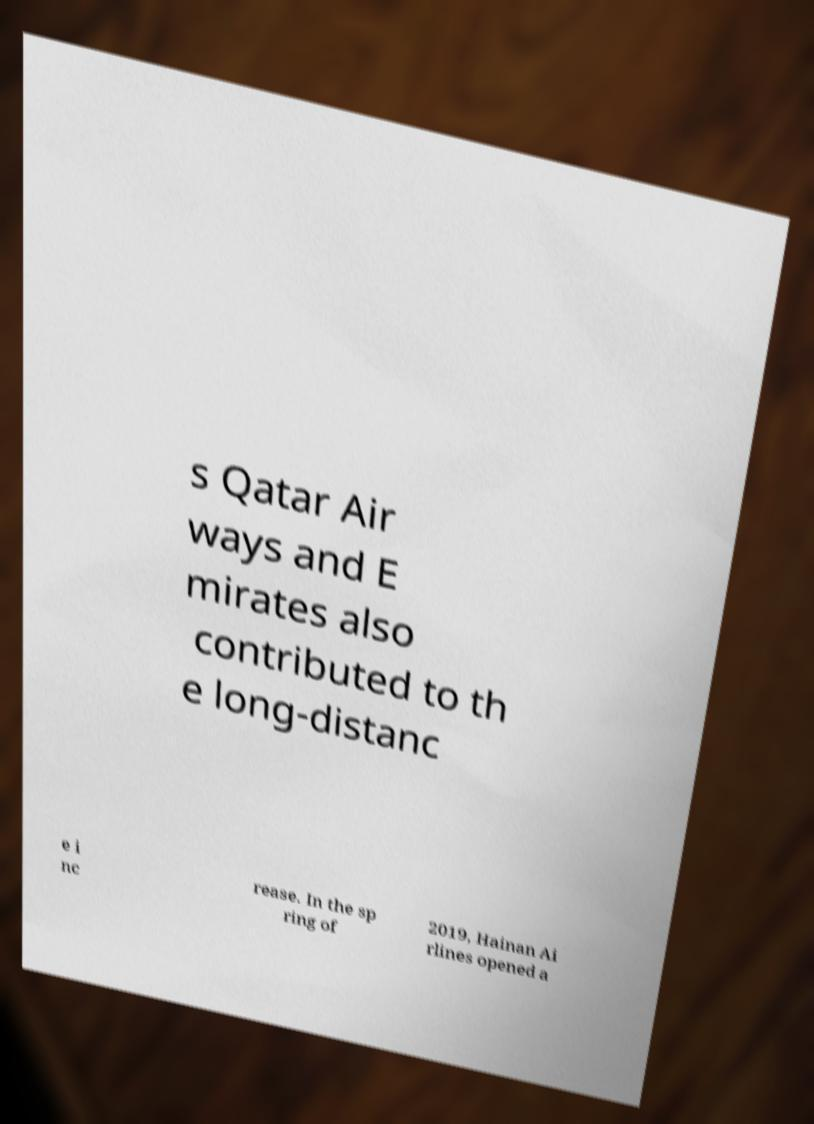Can you accurately transcribe the text from the provided image for me? s Qatar Air ways and E mirates also contributed to th e long-distanc e i nc rease. In the sp ring of 2019, Hainan Ai rlines opened a 